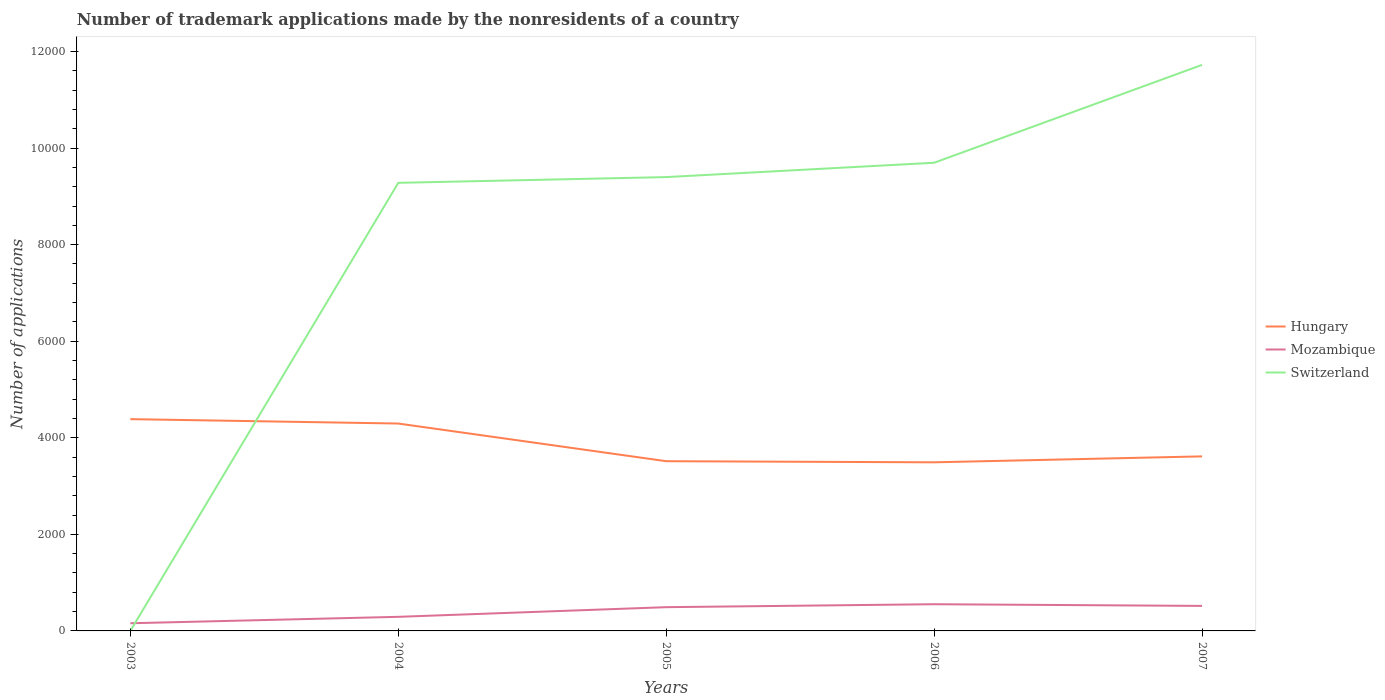How many different coloured lines are there?
Provide a succinct answer. 3. Is the number of lines equal to the number of legend labels?
Provide a short and direct response. Yes. In which year was the number of trademark applications made by the nonresidents in Hungary maximum?
Your response must be concise. 2006. What is the total number of trademark applications made by the nonresidents in Mozambique in the graph?
Offer a very short reply. -226. What is the difference between the highest and the second highest number of trademark applications made by the nonresidents in Mozambique?
Your answer should be very brief. 394. How many lines are there?
Give a very brief answer. 3. How many years are there in the graph?
Ensure brevity in your answer.  5. What is the difference between two consecutive major ticks on the Y-axis?
Your answer should be very brief. 2000. Where does the legend appear in the graph?
Offer a very short reply. Center right. How many legend labels are there?
Your answer should be compact. 3. How are the legend labels stacked?
Offer a very short reply. Vertical. What is the title of the graph?
Your answer should be compact. Number of trademark applications made by the nonresidents of a country. What is the label or title of the X-axis?
Offer a terse response. Years. What is the label or title of the Y-axis?
Your answer should be very brief. Number of applications. What is the Number of applications in Hungary in 2003?
Your answer should be very brief. 4386. What is the Number of applications of Mozambique in 2003?
Offer a very short reply. 159. What is the Number of applications in Hungary in 2004?
Ensure brevity in your answer.  4295. What is the Number of applications in Mozambique in 2004?
Provide a short and direct response. 292. What is the Number of applications in Switzerland in 2004?
Provide a succinct answer. 9280. What is the Number of applications in Hungary in 2005?
Your response must be concise. 3515. What is the Number of applications in Mozambique in 2005?
Offer a very short reply. 492. What is the Number of applications of Switzerland in 2005?
Provide a short and direct response. 9399. What is the Number of applications in Hungary in 2006?
Your response must be concise. 3492. What is the Number of applications of Mozambique in 2006?
Offer a terse response. 553. What is the Number of applications in Switzerland in 2006?
Keep it short and to the point. 9696. What is the Number of applications of Hungary in 2007?
Ensure brevity in your answer.  3615. What is the Number of applications in Mozambique in 2007?
Ensure brevity in your answer.  518. What is the Number of applications in Switzerland in 2007?
Provide a succinct answer. 1.17e+04. Across all years, what is the maximum Number of applications of Hungary?
Your response must be concise. 4386. Across all years, what is the maximum Number of applications in Mozambique?
Keep it short and to the point. 553. Across all years, what is the maximum Number of applications in Switzerland?
Your answer should be very brief. 1.17e+04. Across all years, what is the minimum Number of applications of Hungary?
Your answer should be compact. 3492. Across all years, what is the minimum Number of applications of Mozambique?
Give a very brief answer. 159. Across all years, what is the minimum Number of applications of Switzerland?
Keep it short and to the point. 1. What is the total Number of applications in Hungary in the graph?
Your answer should be very brief. 1.93e+04. What is the total Number of applications of Mozambique in the graph?
Ensure brevity in your answer.  2014. What is the total Number of applications of Switzerland in the graph?
Offer a very short reply. 4.01e+04. What is the difference between the Number of applications in Hungary in 2003 and that in 2004?
Make the answer very short. 91. What is the difference between the Number of applications in Mozambique in 2003 and that in 2004?
Your response must be concise. -133. What is the difference between the Number of applications of Switzerland in 2003 and that in 2004?
Your answer should be very brief. -9279. What is the difference between the Number of applications in Hungary in 2003 and that in 2005?
Your answer should be compact. 871. What is the difference between the Number of applications of Mozambique in 2003 and that in 2005?
Your answer should be very brief. -333. What is the difference between the Number of applications of Switzerland in 2003 and that in 2005?
Keep it short and to the point. -9398. What is the difference between the Number of applications of Hungary in 2003 and that in 2006?
Your answer should be compact. 894. What is the difference between the Number of applications in Mozambique in 2003 and that in 2006?
Keep it short and to the point. -394. What is the difference between the Number of applications in Switzerland in 2003 and that in 2006?
Offer a very short reply. -9695. What is the difference between the Number of applications of Hungary in 2003 and that in 2007?
Provide a succinct answer. 771. What is the difference between the Number of applications of Mozambique in 2003 and that in 2007?
Your answer should be compact. -359. What is the difference between the Number of applications of Switzerland in 2003 and that in 2007?
Offer a very short reply. -1.17e+04. What is the difference between the Number of applications in Hungary in 2004 and that in 2005?
Your response must be concise. 780. What is the difference between the Number of applications in Mozambique in 2004 and that in 2005?
Make the answer very short. -200. What is the difference between the Number of applications of Switzerland in 2004 and that in 2005?
Offer a very short reply. -119. What is the difference between the Number of applications in Hungary in 2004 and that in 2006?
Your answer should be compact. 803. What is the difference between the Number of applications of Mozambique in 2004 and that in 2006?
Provide a short and direct response. -261. What is the difference between the Number of applications in Switzerland in 2004 and that in 2006?
Provide a short and direct response. -416. What is the difference between the Number of applications of Hungary in 2004 and that in 2007?
Your answer should be very brief. 680. What is the difference between the Number of applications in Mozambique in 2004 and that in 2007?
Provide a short and direct response. -226. What is the difference between the Number of applications of Switzerland in 2004 and that in 2007?
Your answer should be very brief. -2443. What is the difference between the Number of applications of Mozambique in 2005 and that in 2006?
Provide a succinct answer. -61. What is the difference between the Number of applications in Switzerland in 2005 and that in 2006?
Offer a terse response. -297. What is the difference between the Number of applications in Hungary in 2005 and that in 2007?
Give a very brief answer. -100. What is the difference between the Number of applications of Switzerland in 2005 and that in 2007?
Keep it short and to the point. -2324. What is the difference between the Number of applications in Hungary in 2006 and that in 2007?
Give a very brief answer. -123. What is the difference between the Number of applications of Mozambique in 2006 and that in 2007?
Ensure brevity in your answer.  35. What is the difference between the Number of applications in Switzerland in 2006 and that in 2007?
Make the answer very short. -2027. What is the difference between the Number of applications in Hungary in 2003 and the Number of applications in Mozambique in 2004?
Provide a short and direct response. 4094. What is the difference between the Number of applications in Hungary in 2003 and the Number of applications in Switzerland in 2004?
Offer a very short reply. -4894. What is the difference between the Number of applications of Mozambique in 2003 and the Number of applications of Switzerland in 2004?
Provide a short and direct response. -9121. What is the difference between the Number of applications of Hungary in 2003 and the Number of applications of Mozambique in 2005?
Keep it short and to the point. 3894. What is the difference between the Number of applications of Hungary in 2003 and the Number of applications of Switzerland in 2005?
Ensure brevity in your answer.  -5013. What is the difference between the Number of applications of Mozambique in 2003 and the Number of applications of Switzerland in 2005?
Your answer should be very brief. -9240. What is the difference between the Number of applications of Hungary in 2003 and the Number of applications of Mozambique in 2006?
Give a very brief answer. 3833. What is the difference between the Number of applications in Hungary in 2003 and the Number of applications in Switzerland in 2006?
Your answer should be compact. -5310. What is the difference between the Number of applications in Mozambique in 2003 and the Number of applications in Switzerland in 2006?
Ensure brevity in your answer.  -9537. What is the difference between the Number of applications of Hungary in 2003 and the Number of applications of Mozambique in 2007?
Make the answer very short. 3868. What is the difference between the Number of applications of Hungary in 2003 and the Number of applications of Switzerland in 2007?
Your answer should be very brief. -7337. What is the difference between the Number of applications in Mozambique in 2003 and the Number of applications in Switzerland in 2007?
Your answer should be very brief. -1.16e+04. What is the difference between the Number of applications of Hungary in 2004 and the Number of applications of Mozambique in 2005?
Give a very brief answer. 3803. What is the difference between the Number of applications of Hungary in 2004 and the Number of applications of Switzerland in 2005?
Your answer should be very brief. -5104. What is the difference between the Number of applications in Mozambique in 2004 and the Number of applications in Switzerland in 2005?
Ensure brevity in your answer.  -9107. What is the difference between the Number of applications of Hungary in 2004 and the Number of applications of Mozambique in 2006?
Your answer should be very brief. 3742. What is the difference between the Number of applications of Hungary in 2004 and the Number of applications of Switzerland in 2006?
Offer a terse response. -5401. What is the difference between the Number of applications in Mozambique in 2004 and the Number of applications in Switzerland in 2006?
Your answer should be compact. -9404. What is the difference between the Number of applications of Hungary in 2004 and the Number of applications of Mozambique in 2007?
Offer a very short reply. 3777. What is the difference between the Number of applications of Hungary in 2004 and the Number of applications of Switzerland in 2007?
Keep it short and to the point. -7428. What is the difference between the Number of applications of Mozambique in 2004 and the Number of applications of Switzerland in 2007?
Provide a succinct answer. -1.14e+04. What is the difference between the Number of applications in Hungary in 2005 and the Number of applications in Mozambique in 2006?
Your answer should be compact. 2962. What is the difference between the Number of applications in Hungary in 2005 and the Number of applications in Switzerland in 2006?
Give a very brief answer. -6181. What is the difference between the Number of applications in Mozambique in 2005 and the Number of applications in Switzerland in 2006?
Make the answer very short. -9204. What is the difference between the Number of applications in Hungary in 2005 and the Number of applications in Mozambique in 2007?
Your answer should be very brief. 2997. What is the difference between the Number of applications of Hungary in 2005 and the Number of applications of Switzerland in 2007?
Provide a succinct answer. -8208. What is the difference between the Number of applications in Mozambique in 2005 and the Number of applications in Switzerland in 2007?
Your answer should be compact. -1.12e+04. What is the difference between the Number of applications of Hungary in 2006 and the Number of applications of Mozambique in 2007?
Ensure brevity in your answer.  2974. What is the difference between the Number of applications of Hungary in 2006 and the Number of applications of Switzerland in 2007?
Offer a very short reply. -8231. What is the difference between the Number of applications of Mozambique in 2006 and the Number of applications of Switzerland in 2007?
Your answer should be very brief. -1.12e+04. What is the average Number of applications in Hungary per year?
Offer a terse response. 3860.6. What is the average Number of applications of Mozambique per year?
Provide a short and direct response. 402.8. What is the average Number of applications of Switzerland per year?
Make the answer very short. 8019.8. In the year 2003, what is the difference between the Number of applications of Hungary and Number of applications of Mozambique?
Your answer should be compact. 4227. In the year 2003, what is the difference between the Number of applications in Hungary and Number of applications in Switzerland?
Offer a terse response. 4385. In the year 2003, what is the difference between the Number of applications of Mozambique and Number of applications of Switzerland?
Your response must be concise. 158. In the year 2004, what is the difference between the Number of applications of Hungary and Number of applications of Mozambique?
Keep it short and to the point. 4003. In the year 2004, what is the difference between the Number of applications in Hungary and Number of applications in Switzerland?
Keep it short and to the point. -4985. In the year 2004, what is the difference between the Number of applications in Mozambique and Number of applications in Switzerland?
Your answer should be compact. -8988. In the year 2005, what is the difference between the Number of applications of Hungary and Number of applications of Mozambique?
Provide a short and direct response. 3023. In the year 2005, what is the difference between the Number of applications in Hungary and Number of applications in Switzerland?
Give a very brief answer. -5884. In the year 2005, what is the difference between the Number of applications of Mozambique and Number of applications of Switzerland?
Give a very brief answer. -8907. In the year 2006, what is the difference between the Number of applications of Hungary and Number of applications of Mozambique?
Offer a very short reply. 2939. In the year 2006, what is the difference between the Number of applications of Hungary and Number of applications of Switzerland?
Your response must be concise. -6204. In the year 2006, what is the difference between the Number of applications of Mozambique and Number of applications of Switzerland?
Your response must be concise. -9143. In the year 2007, what is the difference between the Number of applications of Hungary and Number of applications of Mozambique?
Ensure brevity in your answer.  3097. In the year 2007, what is the difference between the Number of applications in Hungary and Number of applications in Switzerland?
Offer a very short reply. -8108. In the year 2007, what is the difference between the Number of applications in Mozambique and Number of applications in Switzerland?
Give a very brief answer. -1.12e+04. What is the ratio of the Number of applications in Hungary in 2003 to that in 2004?
Your answer should be very brief. 1.02. What is the ratio of the Number of applications in Mozambique in 2003 to that in 2004?
Provide a succinct answer. 0.54. What is the ratio of the Number of applications in Switzerland in 2003 to that in 2004?
Give a very brief answer. 0. What is the ratio of the Number of applications of Hungary in 2003 to that in 2005?
Give a very brief answer. 1.25. What is the ratio of the Number of applications in Mozambique in 2003 to that in 2005?
Your answer should be compact. 0.32. What is the ratio of the Number of applications in Switzerland in 2003 to that in 2005?
Make the answer very short. 0. What is the ratio of the Number of applications in Hungary in 2003 to that in 2006?
Provide a short and direct response. 1.26. What is the ratio of the Number of applications of Mozambique in 2003 to that in 2006?
Give a very brief answer. 0.29. What is the ratio of the Number of applications of Hungary in 2003 to that in 2007?
Ensure brevity in your answer.  1.21. What is the ratio of the Number of applications in Mozambique in 2003 to that in 2007?
Offer a terse response. 0.31. What is the ratio of the Number of applications in Hungary in 2004 to that in 2005?
Make the answer very short. 1.22. What is the ratio of the Number of applications in Mozambique in 2004 to that in 2005?
Give a very brief answer. 0.59. What is the ratio of the Number of applications of Switzerland in 2004 to that in 2005?
Offer a very short reply. 0.99. What is the ratio of the Number of applications of Hungary in 2004 to that in 2006?
Give a very brief answer. 1.23. What is the ratio of the Number of applications of Mozambique in 2004 to that in 2006?
Your answer should be compact. 0.53. What is the ratio of the Number of applications of Switzerland in 2004 to that in 2006?
Ensure brevity in your answer.  0.96. What is the ratio of the Number of applications of Hungary in 2004 to that in 2007?
Offer a very short reply. 1.19. What is the ratio of the Number of applications in Mozambique in 2004 to that in 2007?
Provide a short and direct response. 0.56. What is the ratio of the Number of applications of Switzerland in 2004 to that in 2007?
Offer a very short reply. 0.79. What is the ratio of the Number of applications in Hungary in 2005 to that in 2006?
Ensure brevity in your answer.  1.01. What is the ratio of the Number of applications of Mozambique in 2005 to that in 2006?
Provide a short and direct response. 0.89. What is the ratio of the Number of applications in Switzerland in 2005 to that in 2006?
Offer a very short reply. 0.97. What is the ratio of the Number of applications of Hungary in 2005 to that in 2007?
Keep it short and to the point. 0.97. What is the ratio of the Number of applications in Mozambique in 2005 to that in 2007?
Give a very brief answer. 0.95. What is the ratio of the Number of applications in Switzerland in 2005 to that in 2007?
Ensure brevity in your answer.  0.8. What is the ratio of the Number of applications in Hungary in 2006 to that in 2007?
Your answer should be very brief. 0.97. What is the ratio of the Number of applications of Mozambique in 2006 to that in 2007?
Provide a short and direct response. 1.07. What is the ratio of the Number of applications in Switzerland in 2006 to that in 2007?
Provide a succinct answer. 0.83. What is the difference between the highest and the second highest Number of applications of Hungary?
Ensure brevity in your answer.  91. What is the difference between the highest and the second highest Number of applications of Mozambique?
Provide a short and direct response. 35. What is the difference between the highest and the second highest Number of applications of Switzerland?
Make the answer very short. 2027. What is the difference between the highest and the lowest Number of applications in Hungary?
Your answer should be very brief. 894. What is the difference between the highest and the lowest Number of applications in Mozambique?
Your answer should be very brief. 394. What is the difference between the highest and the lowest Number of applications in Switzerland?
Offer a terse response. 1.17e+04. 